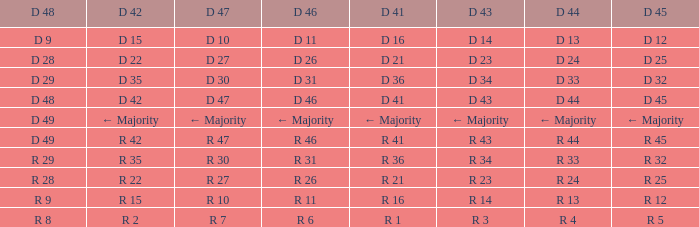Name the D 48 when it has a D 44 of d 33 D 29. Would you mind parsing the complete table? {'header': ['D 48', 'D 42', 'D 47', 'D 46', 'D 41', 'D 43', 'D 44', 'D 45'], 'rows': [['D 9', 'D 15', 'D 10', 'D 11', 'D 16', 'D 14', 'D 13', 'D 12'], ['D 28', 'D 22', 'D 27', 'D 26', 'D 21', 'D 23', 'D 24', 'D 25'], ['D 29', 'D 35', 'D 30', 'D 31', 'D 36', 'D 34', 'D 33', 'D 32'], ['D 48', 'D 42', 'D 47', 'D 46', 'D 41', 'D 43', 'D 44', 'D 45'], ['D 49', '← Majority', '← Majority', '← Majority', '← Majority', '← Majority', '← Majority', '← Majority'], ['D 49', 'R 42', 'R 47', 'R 46', 'R 41', 'R 43', 'R 44', 'R 45'], ['R 29', 'R 35', 'R 30', 'R 31', 'R 36', 'R 34', 'R 33', 'R 32'], ['R 28', 'R 22', 'R 27', 'R 26', 'R 21', 'R 23', 'R 24', 'R 25'], ['R 9', 'R 15', 'R 10', 'R 11', 'R 16', 'R 14', 'R 13', 'R 12'], ['R 8', 'R 2', 'R 7', 'R 6', 'R 1', 'R 3', 'R 4', 'R 5']]} 